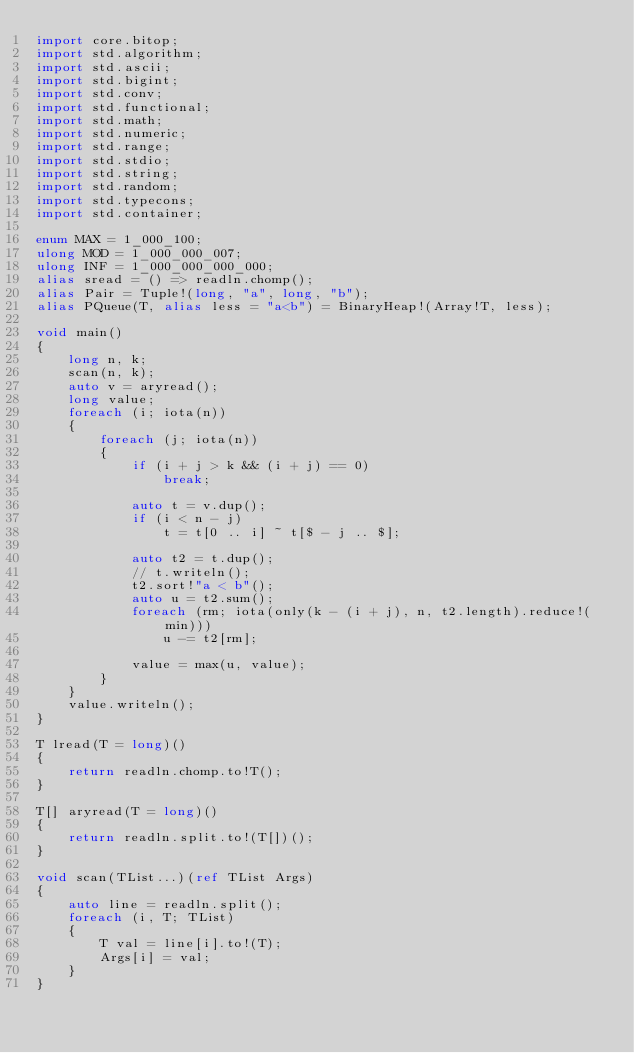<code> <loc_0><loc_0><loc_500><loc_500><_D_>import core.bitop;
import std.algorithm;
import std.ascii;
import std.bigint;
import std.conv;
import std.functional;
import std.math;
import std.numeric;
import std.range;
import std.stdio;
import std.string;
import std.random;
import std.typecons;
import std.container;

enum MAX = 1_000_100;
ulong MOD = 1_000_000_007;
ulong INF = 1_000_000_000_000;
alias sread = () => readln.chomp();
alias Pair = Tuple!(long, "a", long, "b");
alias PQueue(T, alias less = "a<b") = BinaryHeap!(Array!T, less);

void main()
{
    long n, k;
    scan(n, k);
    auto v = aryread();
    long value;
    foreach (i; iota(n))
    {
        foreach (j; iota(n))
        {
            if (i + j > k && (i + j) == 0)
                break;

            auto t = v.dup();
            if (i < n - j)
                t = t[0 .. i] ~ t[$ - j .. $];
                
            auto t2 = t.dup();
            // t.writeln();
            t2.sort!"a < b"();
            auto u = t2.sum();
            foreach (rm; iota(only(k - (i + j), n, t2.length).reduce!(min)))
                u -= t2[rm];

            value = max(u, value);
        }
    }
    value.writeln();
}

T lread(T = long)()
{
    return readln.chomp.to!T();
}

T[] aryread(T = long)()
{
    return readln.split.to!(T[])();
}

void scan(TList...)(ref TList Args)
{
    auto line = readln.split();
    foreach (i, T; TList)
    {
        T val = line[i].to!(T);
        Args[i] = val;
    }
}
</code> 